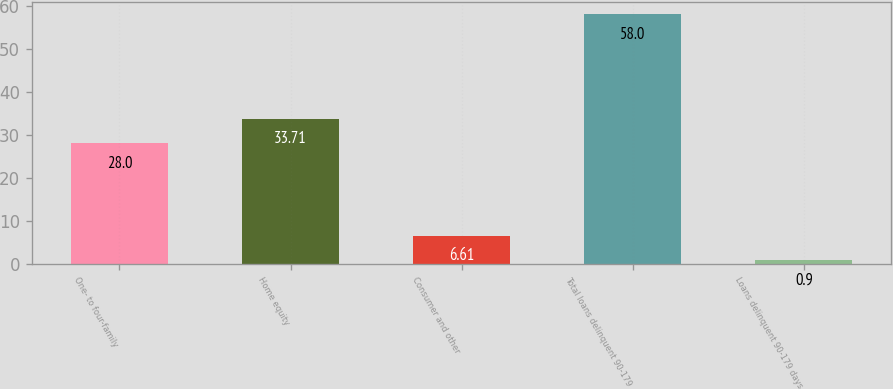<chart> <loc_0><loc_0><loc_500><loc_500><bar_chart><fcel>One- to four-family<fcel>Home equity<fcel>Consumer and other<fcel>Total loans delinquent 90-179<fcel>Loans delinquent 90-179 days<nl><fcel>28<fcel>33.71<fcel>6.61<fcel>58<fcel>0.9<nl></chart> 